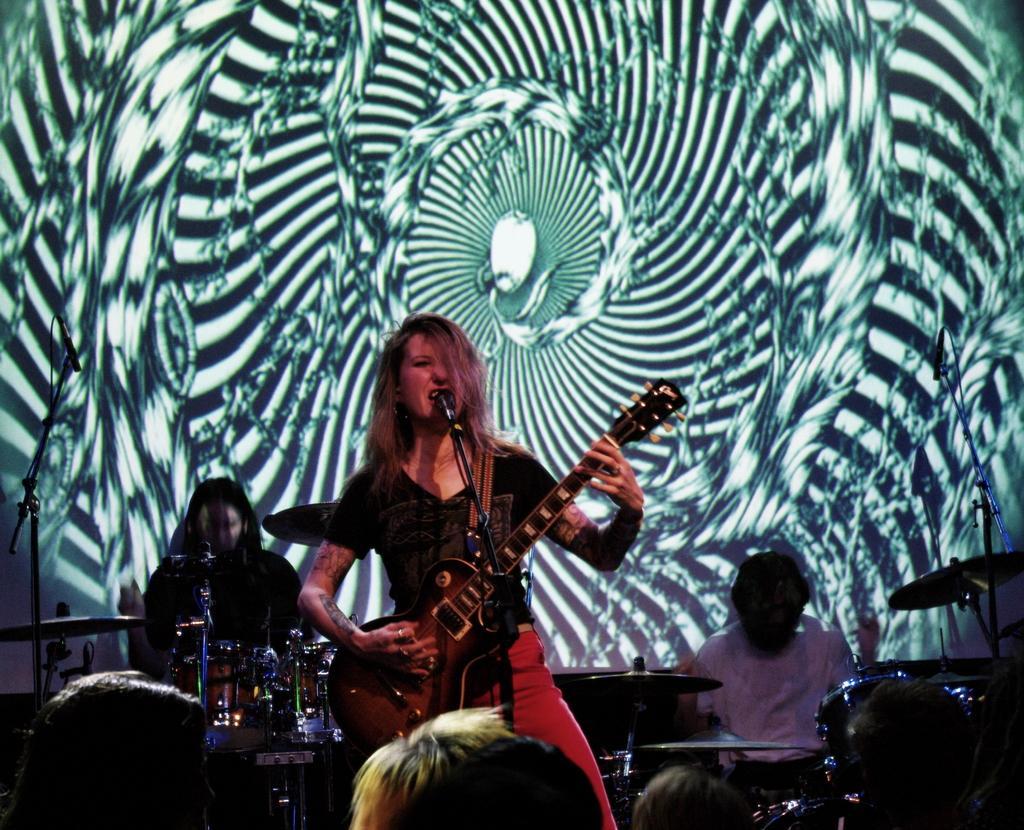Can you describe this image briefly? In the center of the image there is a lady playing a guitar. She is singing a song. There is a mic placed before her. In the background there are people who are playing band and drums. At the bottom there is a crowd. We can also see a screen. 